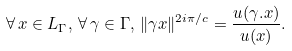<formula> <loc_0><loc_0><loc_500><loc_500>\forall \, x \in L _ { \Gamma } , \, \forall \, \gamma \in \Gamma , \, \| \gamma x \| ^ { 2 i \pi \slash c } = \frac { u ( \gamma . x ) } { u ( x ) } .</formula> 